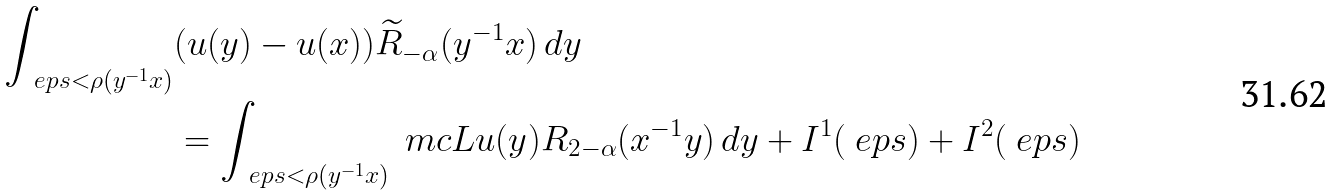<formula> <loc_0><loc_0><loc_500><loc_500>\int _ { \ e p s < \rho ( y ^ { - 1 } x ) } & ( u ( y ) - u ( x ) ) \widetilde { R } _ { - \alpha } ( y ^ { - 1 } x ) \, d y \\ & = \int _ { \ e p s < \rho ( y ^ { - 1 } x ) } \ m c L u ( y ) R _ { 2 - \alpha } ( x ^ { - 1 } y ) \, d y + I ^ { 1 } ( \ e p s ) + I ^ { 2 } ( \ e p s )</formula> 